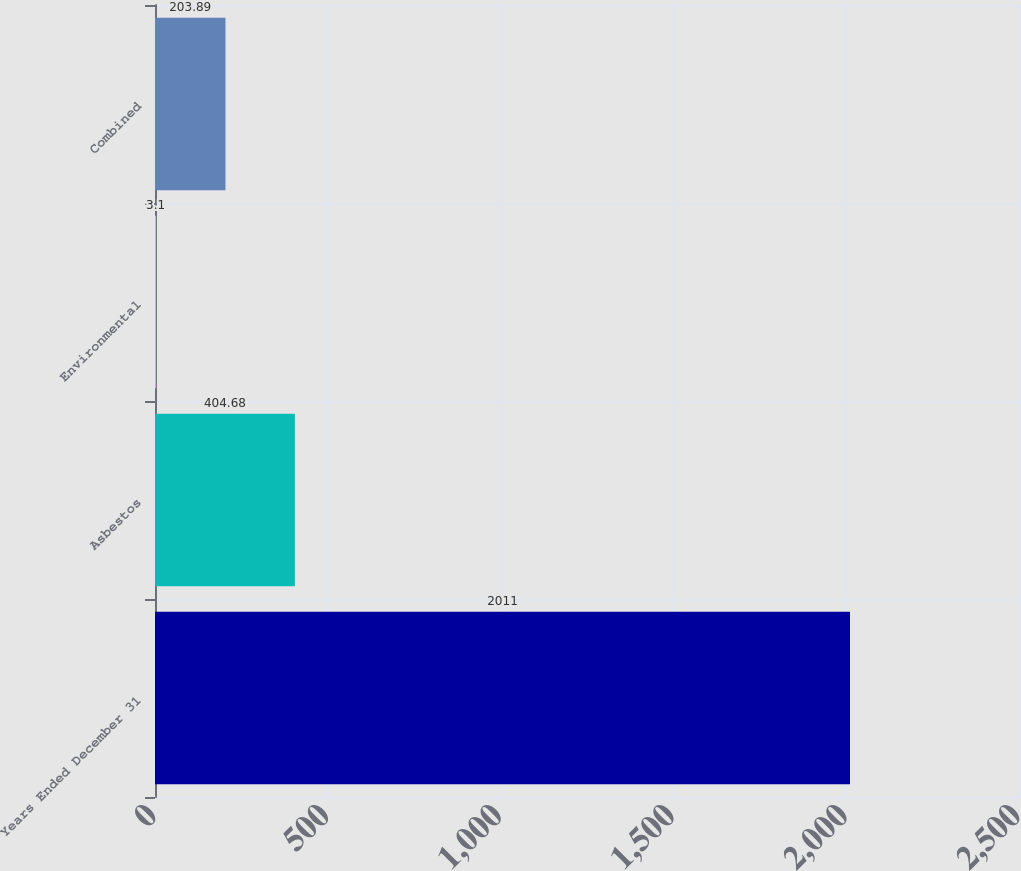Convert chart. <chart><loc_0><loc_0><loc_500><loc_500><bar_chart><fcel>Years Ended December 31<fcel>Asbestos<fcel>Environmental<fcel>Combined<nl><fcel>2011<fcel>404.68<fcel>3.1<fcel>203.89<nl></chart> 